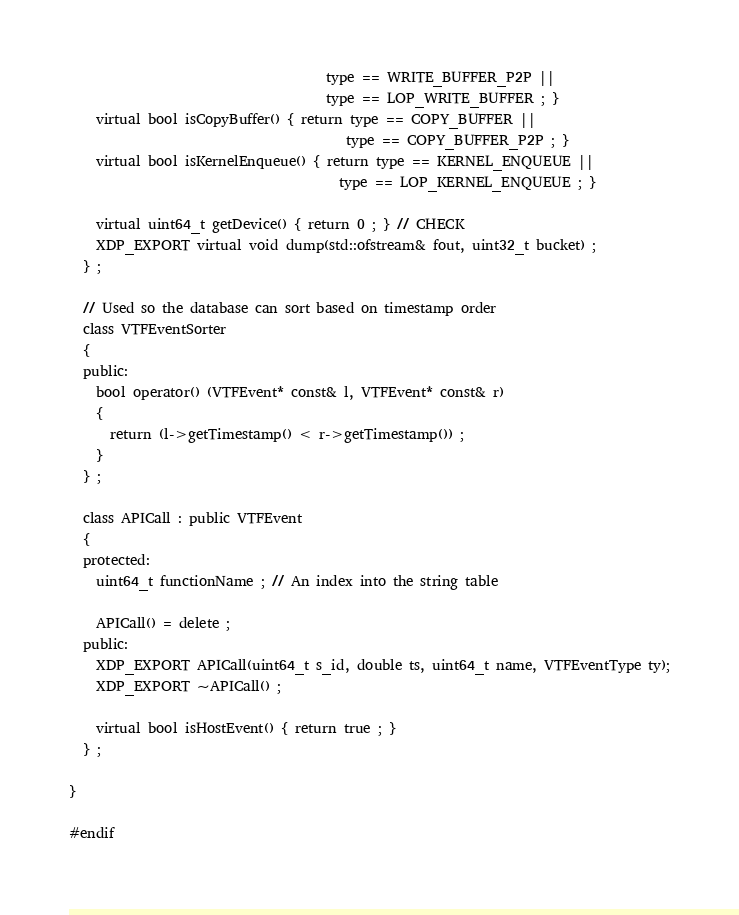Convert code to text. <code><loc_0><loc_0><loc_500><loc_500><_C_>	                                  type == WRITE_BUFFER_P2P ||
	                                  type == LOP_WRITE_BUFFER ; }
    virtual bool isCopyBuffer() { return type == COPY_BUFFER ||
                                         type == COPY_BUFFER_P2P ; }
    virtual bool isKernelEnqueue() { return type == KERNEL_ENQUEUE ||
	                                    type == LOP_KERNEL_ENQUEUE ; }

    virtual uint64_t getDevice() { return 0 ; } // CHECK
    XDP_EXPORT virtual void dump(std::ofstream& fout, uint32_t bucket) ;
  } ;

  // Used so the database can sort based on timestamp order
  class VTFEventSorter
  {
  public:
    bool operator() (VTFEvent* const& l, VTFEvent* const& r)
    {
      return (l->getTimestamp() < r->getTimestamp()) ;
    }
  } ;
 
  class APICall : public VTFEvent 
  {
  protected:
    uint64_t functionName ; // An index into the string table

    APICall() = delete ;
  public:
    XDP_EXPORT APICall(uint64_t s_id, double ts, uint64_t name, VTFEventType ty);
    XDP_EXPORT ~APICall() ;

    virtual bool isHostEvent() { return true ; } 
  } ;
 
}

#endif
</code> 